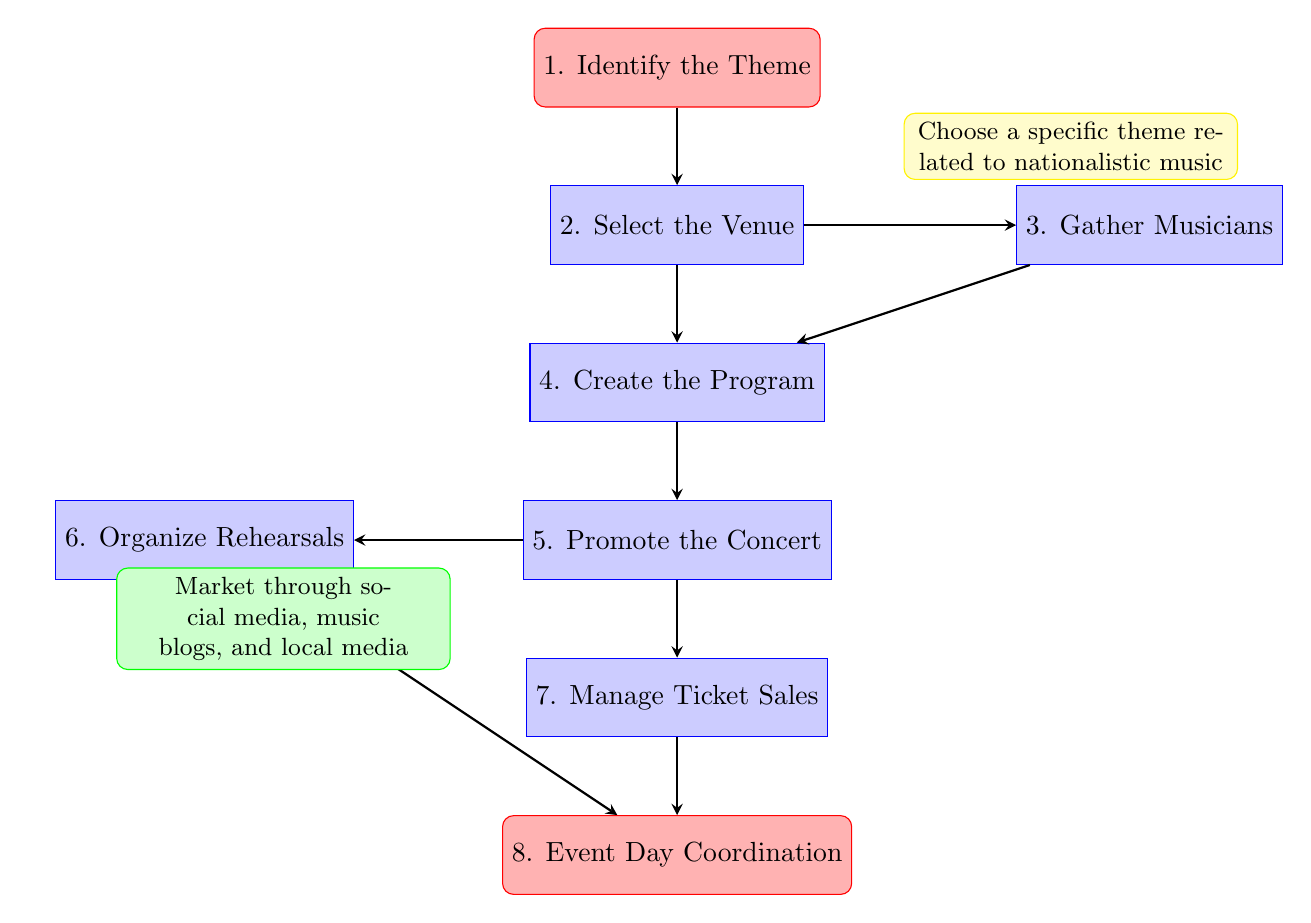What is the first step in organizing a nationalistic music concert? The flow chart indicates that the first step is "Identify the Theme." This is the starting point of the process.
Answer: Identify the Theme How many main steps are there in the flow chart? By counting the nodes in the diagram, there are a total of eight main steps listed in the flow chart.
Answer: Eight What follows after selecting the venue? The flow chart shows that after "Select the Venue," the next step is "Create the Program." This indicates the sequential flow of tasks.
Answer: Create the Program Which activities are coordinated after promoting the concert? According to the flow chart, following "Promote the Concert," the next tasks are "Organize Rehearsals" and "Manage Ticket Sales," indicating parallel activities.
Answer: Organize Rehearsals, Manage Ticket Sales What is the last step in the concert organization process? The final step indicated in the flow chart is "Event Day Coordination." This is the conclusion of the outlined steps.
Answer: Event Day Coordination Which step includes marketing through social media? The diagram shows that "Promote the Concert" involves marketing through various channels, including social media and music blogs.
Answer: Promote the Concert What are the two tasks that occur after 'Create the Program'? The flow chart points out that after "Create the Program," the tasks for "Promote the Concert" and gathering musicians are to be done, which are essential for concert organization.
Answer: Promote the Concert, Gather Musicians Which two steps originate from the 'Promote the Concert' node? From the "Promote the Concert" node, the subsequent steps are "Organize Rehearsals" and "Manage Ticket Sales." This indicates the branching of workflows from the promotion phase.
Answer: Organize Rehearsals, Manage Ticket Sales 